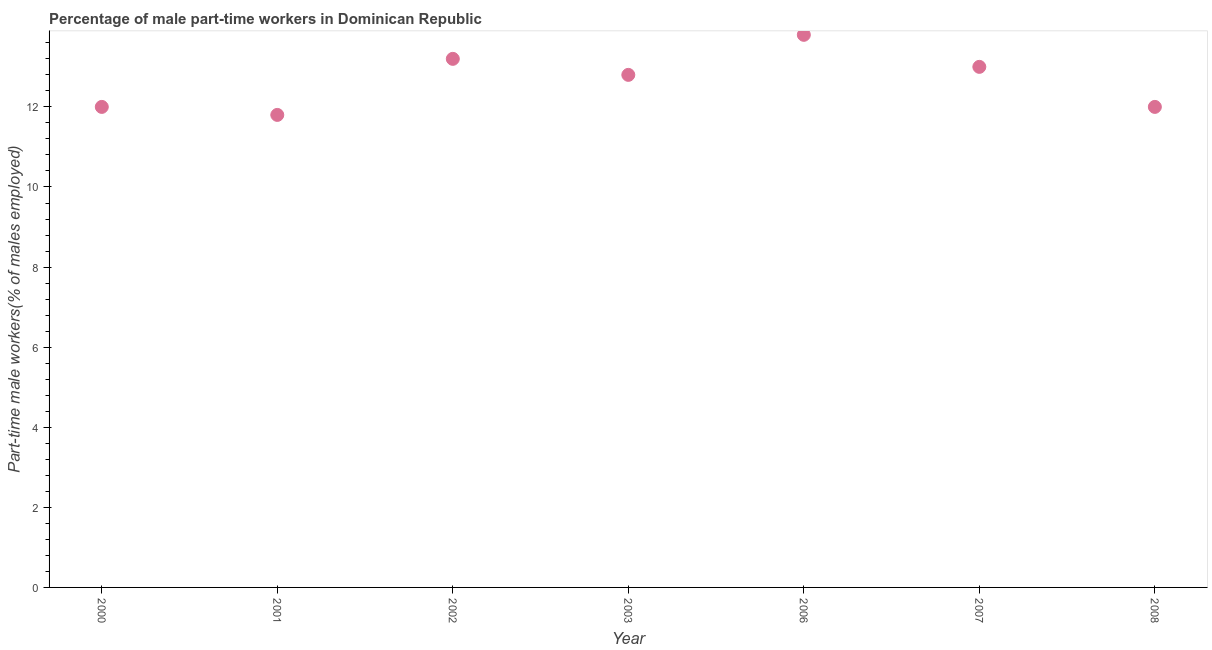What is the percentage of part-time male workers in 2008?
Ensure brevity in your answer.  12. Across all years, what is the maximum percentage of part-time male workers?
Your response must be concise. 13.8. Across all years, what is the minimum percentage of part-time male workers?
Provide a short and direct response. 11.8. In which year was the percentage of part-time male workers maximum?
Give a very brief answer. 2006. What is the sum of the percentage of part-time male workers?
Make the answer very short. 88.6. What is the difference between the percentage of part-time male workers in 2002 and 2007?
Your answer should be compact. 0.2. What is the average percentage of part-time male workers per year?
Make the answer very short. 12.66. What is the median percentage of part-time male workers?
Offer a terse response. 12.8. What is the ratio of the percentage of part-time male workers in 2000 to that in 2003?
Your answer should be compact. 0.94. Is the percentage of part-time male workers in 2002 less than that in 2008?
Your answer should be very brief. No. What is the difference between the highest and the second highest percentage of part-time male workers?
Provide a short and direct response. 0.6. Is the sum of the percentage of part-time male workers in 2000 and 2002 greater than the maximum percentage of part-time male workers across all years?
Provide a short and direct response. Yes. In how many years, is the percentage of part-time male workers greater than the average percentage of part-time male workers taken over all years?
Offer a very short reply. 4. How many dotlines are there?
Your answer should be very brief. 1. How many years are there in the graph?
Make the answer very short. 7. What is the difference between two consecutive major ticks on the Y-axis?
Your answer should be very brief. 2. Does the graph contain grids?
Your response must be concise. No. What is the title of the graph?
Provide a succinct answer. Percentage of male part-time workers in Dominican Republic. What is the label or title of the X-axis?
Ensure brevity in your answer.  Year. What is the label or title of the Y-axis?
Your response must be concise. Part-time male workers(% of males employed). What is the Part-time male workers(% of males employed) in 2001?
Give a very brief answer. 11.8. What is the Part-time male workers(% of males employed) in 2002?
Offer a very short reply. 13.2. What is the Part-time male workers(% of males employed) in 2003?
Your answer should be very brief. 12.8. What is the Part-time male workers(% of males employed) in 2006?
Make the answer very short. 13.8. What is the difference between the Part-time male workers(% of males employed) in 2000 and 2001?
Ensure brevity in your answer.  0.2. What is the difference between the Part-time male workers(% of males employed) in 2000 and 2002?
Your response must be concise. -1.2. What is the difference between the Part-time male workers(% of males employed) in 2000 and 2006?
Provide a succinct answer. -1.8. What is the difference between the Part-time male workers(% of males employed) in 2000 and 2007?
Offer a terse response. -1. What is the difference between the Part-time male workers(% of males employed) in 2001 and 2003?
Offer a terse response. -1. What is the difference between the Part-time male workers(% of males employed) in 2001 and 2006?
Keep it short and to the point. -2. What is the difference between the Part-time male workers(% of males employed) in 2001 and 2007?
Provide a short and direct response. -1.2. What is the difference between the Part-time male workers(% of males employed) in 2001 and 2008?
Your answer should be very brief. -0.2. What is the difference between the Part-time male workers(% of males employed) in 2002 and 2003?
Your answer should be compact. 0.4. What is the difference between the Part-time male workers(% of males employed) in 2002 and 2007?
Offer a terse response. 0.2. What is the difference between the Part-time male workers(% of males employed) in 2003 and 2007?
Offer a terse response. -0.2. What is the difference between the Part-time male workers(% of males employed) in 2006 and 2007?
Keep it short and to the point. 0.8. What is the difference between the Part-time male workers(% of males employed) in 2006 and 2008?
Offer a very short reply. 1.8. What is the ratio of the Part-time male workers(% of males employed) in 2000 to that in 2001?
Ensure brevity in your answer.  1.02. What is the ratio of the Part-time male workers(% of males employed) in 2000 to that in 2002?
Offer a terse response. 0.91. What is the ratio of the Part-time male workers(% of males employed) in 2000 to that in 2003?
Give a very brief answer. 0.94. What is the ratio of the Part-time male workers(% of males employed) in 2000 to that in 2006?
Offer a terse response. 0.87. What is the ratio of the Part-time male workers(% of males employed) in 2000 to that in 2007?
Make the answer very short. 0.92. What is the ratio of the Part-time male workers(% of males employed) in 2001 to that in 2002?
Your response must be concise. 0.89. What is the ratio of the Part-time male workers(% of males employed) in 2001 to that in 2003?
Make the answer very short. 0.92. What is the ratio of the Part-time male workers(% of males employed) in 2001 to that in 2006?
Provide a short and direct response. 0.85. What is the ratio of the Part-time male workers(% of males employed) in 2001 to that in 2007?
Provide a succinct answer. 0.91. What is the ratio of the Part-time male workers(% of males employed) in 2001 to that in 2008?
Offer a very short reply. 0.98. What is the ratio of the Part-time male workers(% of males employed) in 2002 to that in 2003?
Keep it short and to the point. 1.03. What is the ratio of the Part-time male workers(% of males employed) in 2002 to that in 2006?
Provide a succinct answer. 0.96. What is the ratio of the Part-time male workers(% of males employed) in 2002 to that in 2008?
Offer a very short reply. 1.1. What is the ratio of the Part-time male workers(% of males employed) in 2003 to that in 2006?
Provide a short and direct response. 0.93. What is the ratio of the Part-time male workers(% of males employed) in 2003 to that in 2008?
Make the answer very short. 1.07. What is the ratio of the Part-time male workers(% of males employed) in 2006 to that in 2007?
Offer a very short reply. 1.06. What is the ratio of the Part-time male workers(% of males employed) in 2006 to that in 2008?
Your response must be concise. 1.15. What is the ratio of the Part-time male workers(% of males employed) in 2007 to that in 2008?
Offer a very short reply. 1.08. 